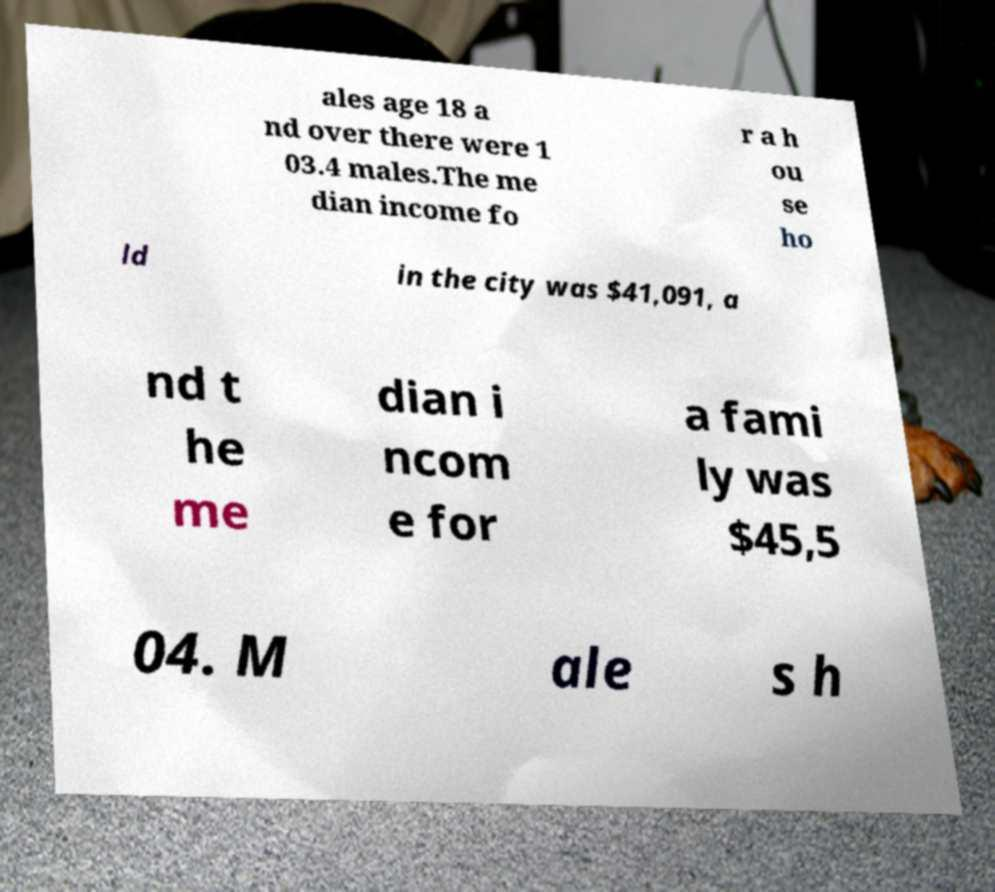Could you extract and type out the text from this image? ales age 18 a nd over there were 1 03.4 males.The me dian income fo r a h ou se ho ld in the city was $41,091, a nd t he me dian i ncom e for a fami ly was $45,5 04. M ale s h 